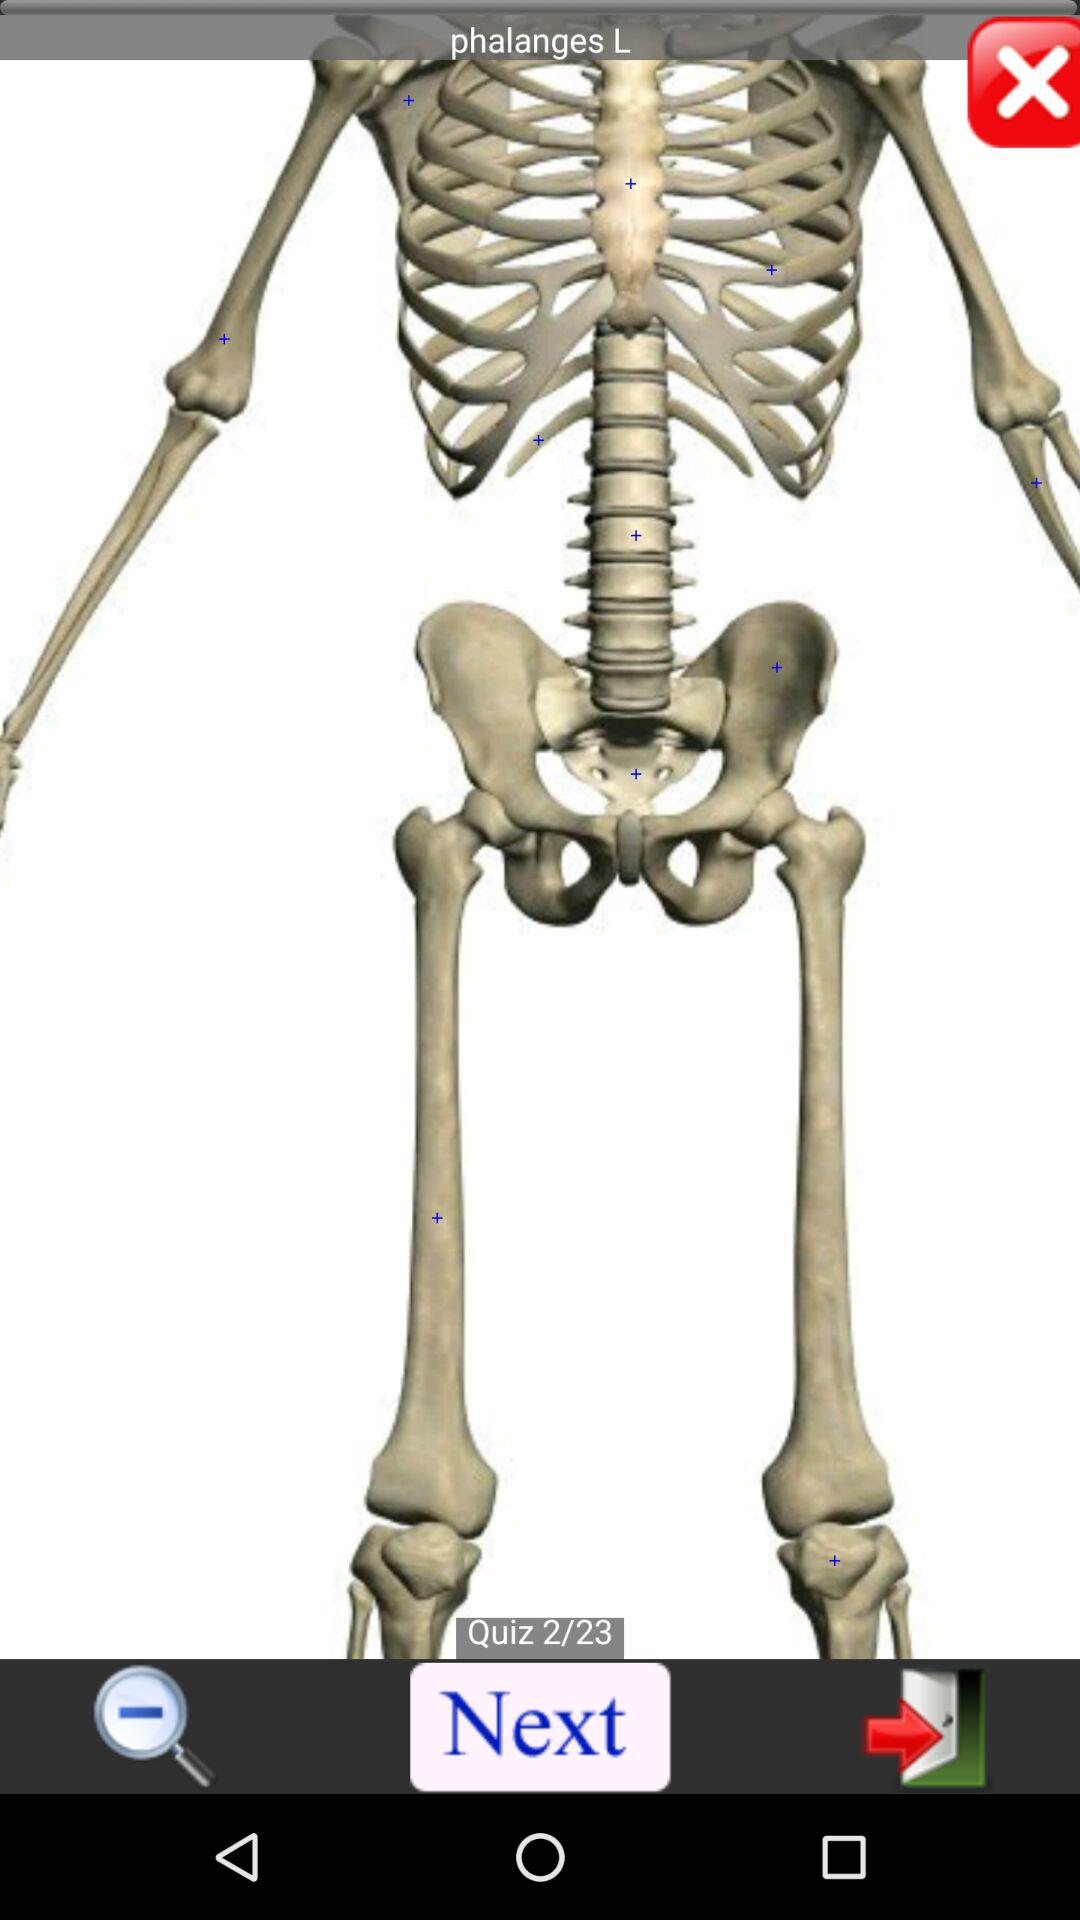On which quiz number are we right now? Right now, you are on quiz number 2. 